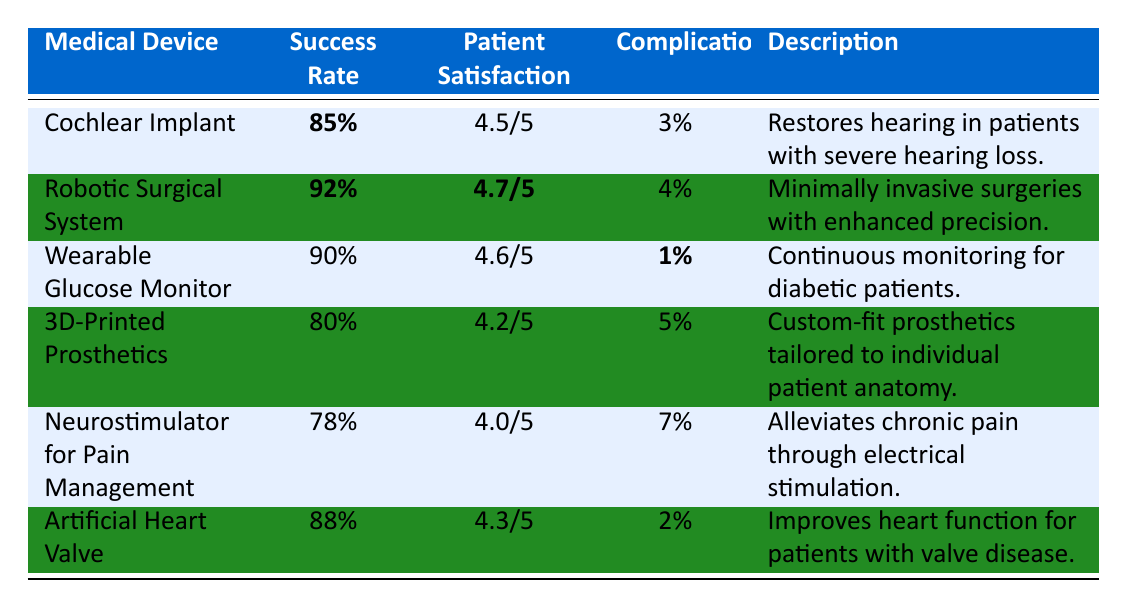What is the success rate of the Robotic Surgical System? The success rate is listed in the table under the corresponding medical device. For the Robotic Surgical System, the success rate is **92%**.
Answer: 92% Which medical device has the highest patient satisfaction score? By examining the patient satisfaction scores in the table, the Robotic Surgical System has the highest score at **4.7/5**.
Answer: 4.7/5 Is the complication rate for the Wearable Glucose Monitor the lowest among the listed devices? The complication rate for the Wearable Glucose Monitor is **1%**, and comparing this with all other devices in the table shows that it is indeed the lowest.
Answer: Yes What is the average patient satisfaction score for all devices? First, we add the patient satisfaction scores (4.5 + 4.7 + 4.6 + 4.2 + 4.0 + 4.3), which totals to 26.3. Since there are 6 devices, the average is 26.3/6 = 4.38.
Answer: 4.38 Which device has the highest success rate and what is that rate? By reviewing the success rates in the table, the Robotic Surgical System has the highest rate at **92%**.
Answer: 92% What is the difference in success rate between the 3D-Printed Prosthetics and the Neurostimulator for Pain Management? The success rate for the 3D-Printed Prosthetics is **80%** and for the Neurostimulator, it is **78%**. The difference is 80% - 78% = 2%.
Answer: 2% Which medical device has the most complications, and what is the rate? In the table, the Neurostimulator for Pain Management has the highest complications at **7%**.
Answer: 7% If a patient is considering a device based on both success rate and complications, which device would be the second choice after the Robotic Surgical System? The Robotic Surgical System has a success rate of **92%** and 4% complications. The next in line is the Wearable Glucose Monitor with a **90%** success rate and **1%** complications. Therefore, the second choice would be the Wearable Glucose Monitor.
Answer: Wearable Glucose Monitor How does the complication rate of the Artificial Heart Valve compare to that of the Cochlear Implant? The complication rate for the Artificial Heart Valve is **2%** while for the Cochlear Implant it is **3%**. Since 2% is less than 3%, the Artificial Heart Valve has a lower complication rate.
Answer: Lower What is the total success rate percentage when combining the success rates of the Cochlear Implant and the Neurostimulator for Pain Management? The success rate for the Cochlear Implant is **85%** and for the Neurostimulator, it is **78%**. The total when combined is 85% + 78% = 163%.
Answer: 163% 